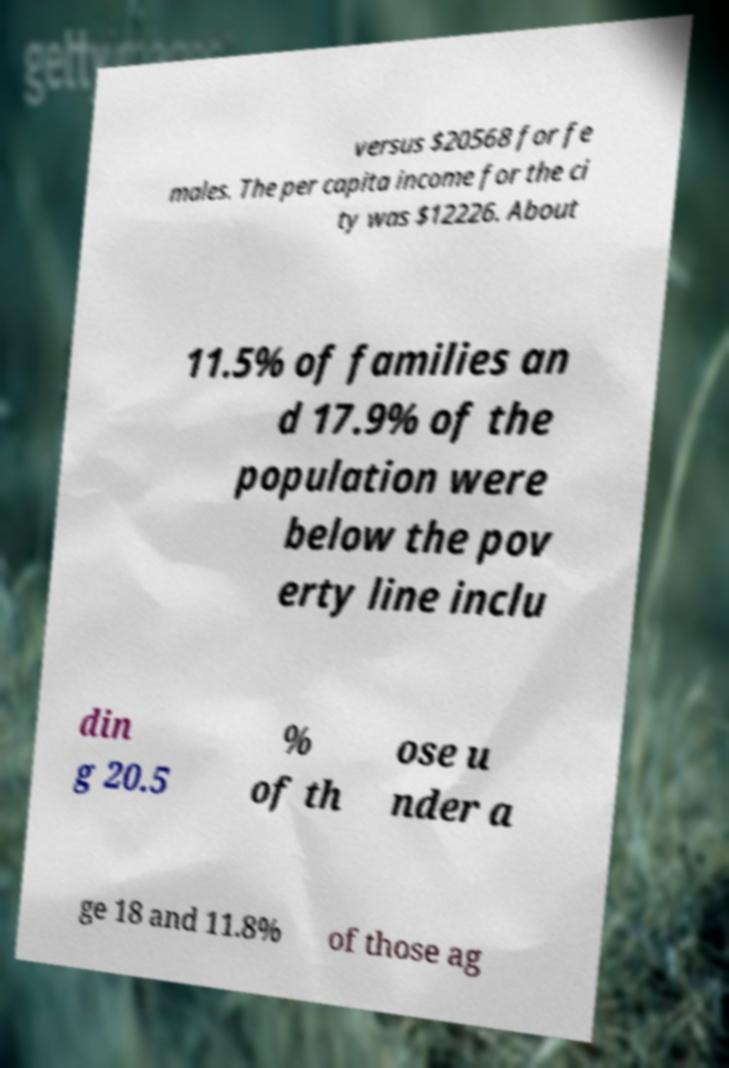Please read and relay the text visible in this image. What does it say? versus $20568 for fe males. The per capita income for the ci ty was $12226. About 11.5% of families an d 17.9% of the population were below the pov erty line inclu din g 20.5 % of th ose u nder a ge 18 and 11.8% of those ag 